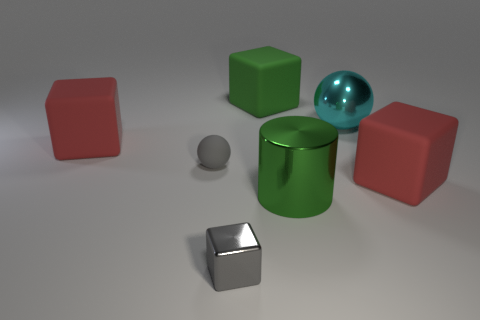What is the size of the block that is the same color as the cylinder?
Provide a succinct answer. Large. Is the color of the large cube that is behind the big cyan object the same as the big metallic cylinder?
Give a very brief answer. Yes. How many other things are the same color as the small rubber thing?
Give a very brief answer. 1. There is a metal object that is the same shape as the gray rubber object; what size is it?
Your response must be concise. Large. Are there an equal number of spheres that are on the left side of the big green block and balls in front of the cyan metal thing?
Your answer should be very brief. Yes. There is a gray object behind the big green metallic thing; how big is it?
Make the answer very short. Small. Is the small shiny block the same color as the small ball?
Ensure brevity in your answer.  Yes. Are there any other things that have the same shape as the green metallic thing?
Make the answer very short. No. There is a tiny thing that is the same color as the tiny matte sphere; what material is it?
Give a very brief answer. Metal. Is the number of big metal objects that are in front of the small gray shiny thing the same as the number of tiny rubber objects?
Keep it short and to the point. No. 